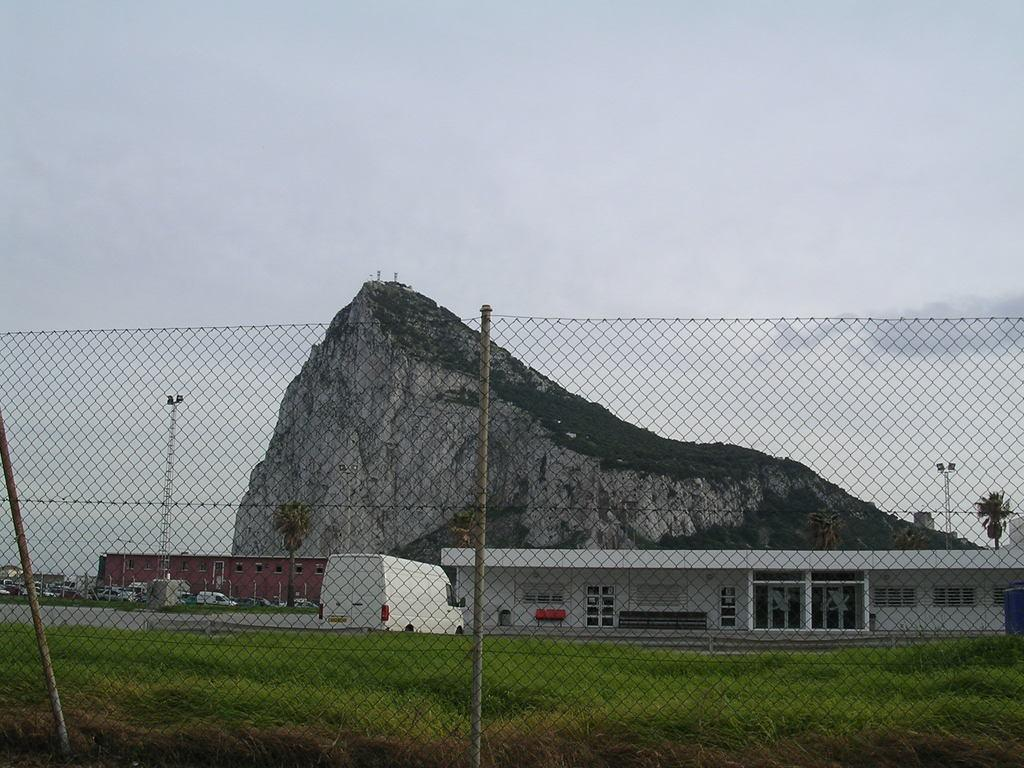What can be seen in the foreground of the image? In the foreground of the image, there is a fence, grass, houses, vehicles on the road, and a tower. What is the terrain like in the foreground of the image? The terrain in the foreground of the image includes grass and a road. What is visible in the background of the image? In the background of the image, there is a mountain and the sky. When was the image taken? The image was taken during the day. How does the feeling of the grass affect the breath of the friend in the image? There is no friend or feeling of the grass mentioned in the image; it only shows a fence, grass, houses, vehicles on the road, a tower, a mountain, the sky, and was taken during the day. 